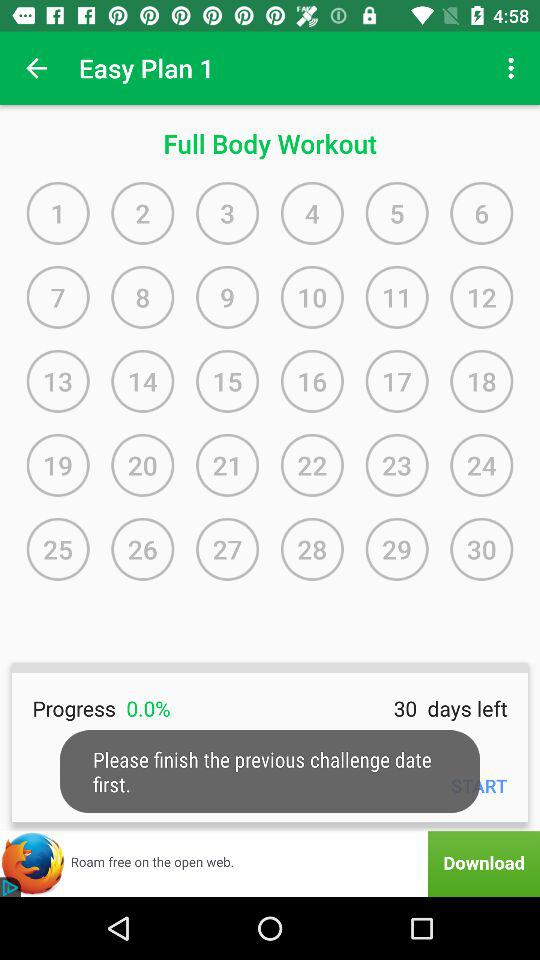What is the progress percentage? The progress is 0 percent. 